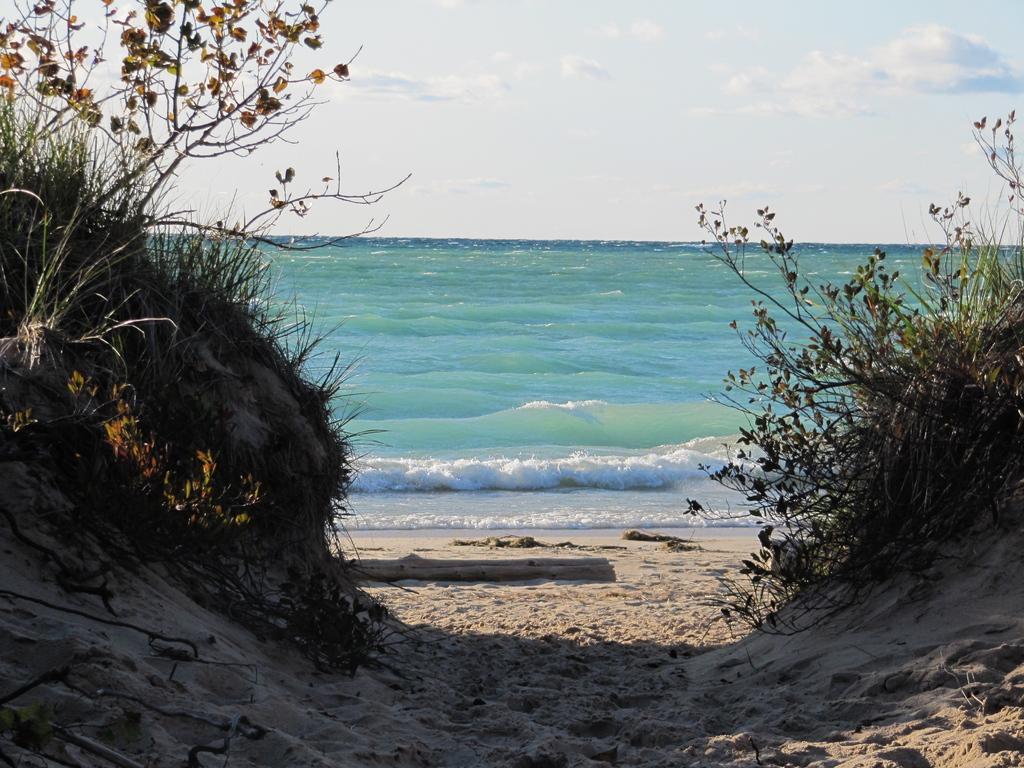Can you describe this image briefly? In this image I can see planets and the water. In the background I can see the sky. 